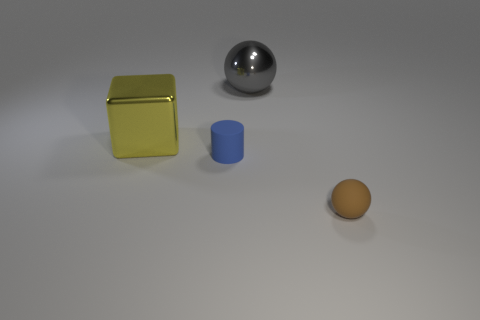Add 3 yellow metal cylinders. How many objects exist? 7 Subtract all gray spheres. How many spheres are left? 1 Add 1 gray things. How many gray things are left? 2 Add 2 large green metallic cylinders. How many large green metallic cylinders exist? 2 Subtract 1 brown balls. How many objects are left? 3 Subtract all cubes. How many objects are left? 3 Subtract 1 balls. How many balls are left? 1 Subtract all brown cylinders. Subtract all red balls. How many cylinders are left? 1 Subtract all large gray spheres. Subtract all small blue matte objects. How many objects are left? 2 